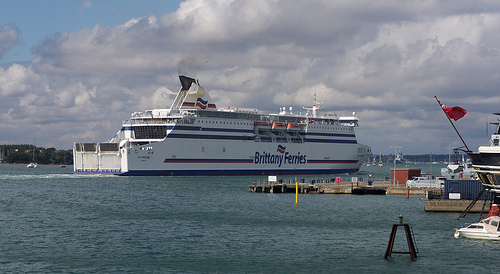Please provide the bounding box coordinate of the region this sentence describes: a red flag. The bounding box coordinates for the red flag are [0.88, 0.43, 0.94, 0.46]. 